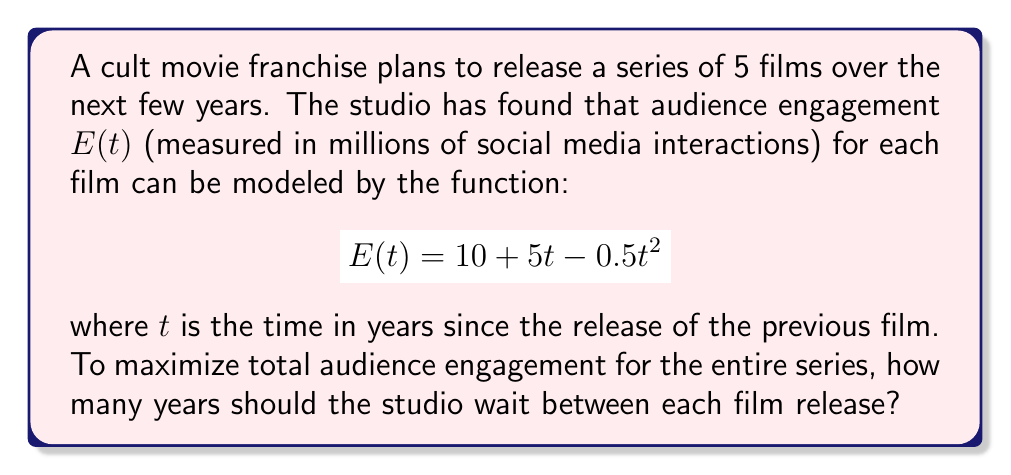Can you solve this math problem? To solve this problem, we need to find the maximum value of the engagement function $E(t)$.

1. First, let's find the derivative of $E(t)$:
   $$E'(t) = 5 - t$$

2. To find the maximum, we set $E'(t) = 0$ and solve for $t$:
   $$5 - t = 0$$
   $$t = 5$$

3. We can confirm this is a maximum by checking the second derivative:
   $$E''(t) = -1$$
   Since $E''(t)$ is negative, we confirm that $t = 5$ gives us a maximum.

4. To verify, let's calculate $E(5)$:
   $$E(5) = 10 + 5(5) - 0.5(5^2) = 10 + 25 - 12.5 = 22.5$$

This means that audience engagement is maximized at 22.5 million interactions when there's a 5-year gap between films.

5. For a cult movie series, maintaining consistent engagement over time is crucial. By spacing out the releases every 5 years, the studio can create a cycle of anticipation and maximize engagement for each film.

Therefore, the optimal release schedule is to wait 5 years between each film in the series.
Answer: The studio should wait 5 years between each film release to maximize total audience engagement for the entire cult movie series. 